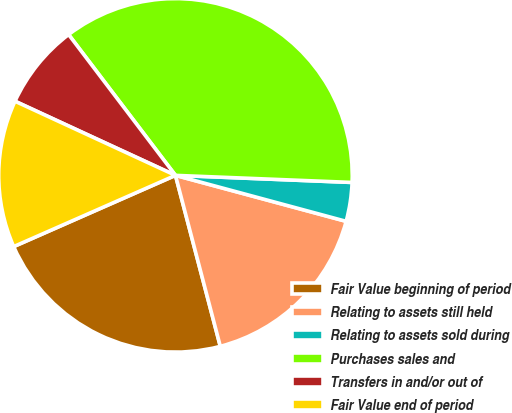<chart> <loc_0><loc_0><loc_500><loc_500><pie_chart><fcel>Fair Value beginning of period<fcel>Relating to assets still held<fcel>Relating to assets sold during<fcel>Purchases sales and<fcel>Transfers in and/or out of<fcel>Fair Value end of period<nl><fcel>22.48%<fcel>16.73%<fcel>3.55%<fcel>35.97%<fcel>7.78%<fcel>13.49%<nl></chart> 